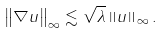<formula> <loc_0><loc_0><loc_500><loc_500>\left \| \nabla u \right \| _ { \infty } \lesssim \sqrt { \lambda } \left \| u \right \| _ { \infty } .</formula> 